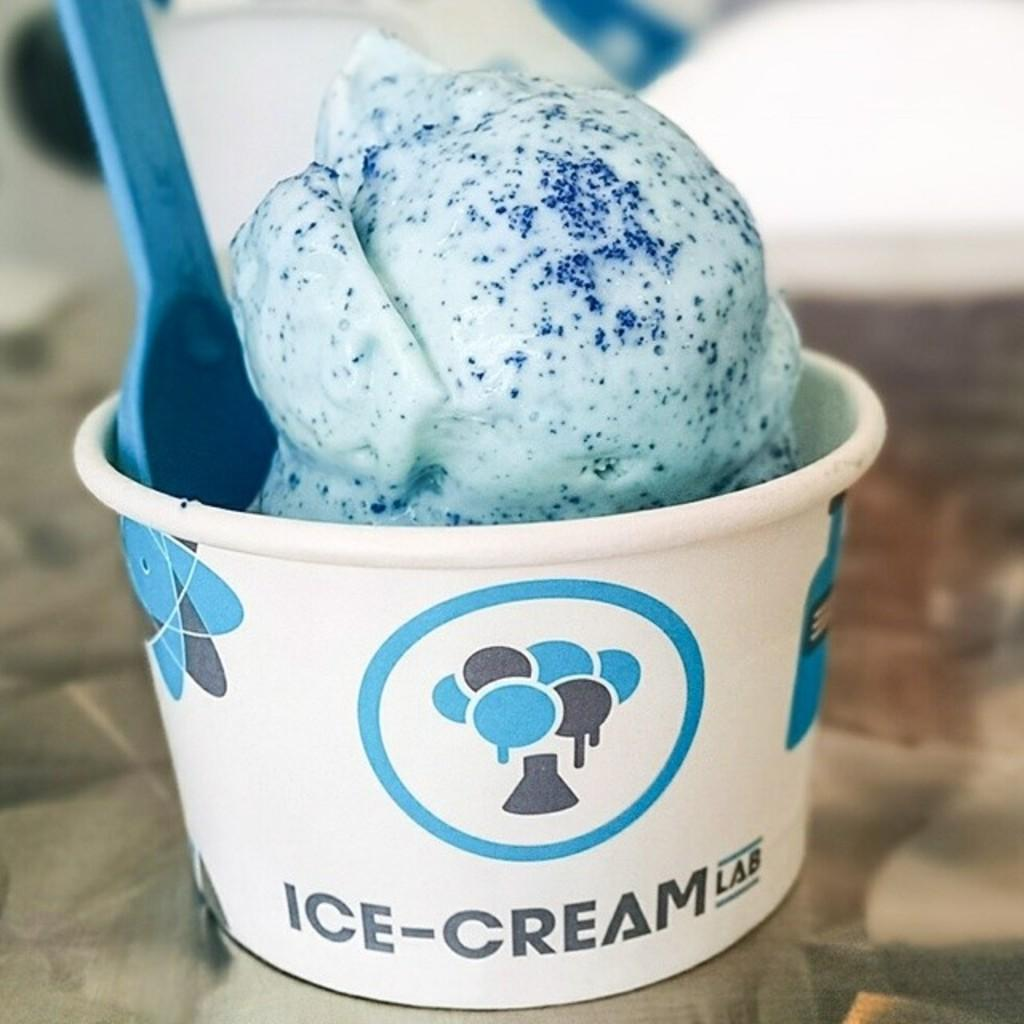What is on the table in the image? There is an ice cream on the table in the image. What else can be seen on the table besides the ice cream? There is a cup in the image. What is inside the cup? The cup contains a cream ball. What is used to eat the cream ball? There is a spoon in the cup. What is written on the cup? The cup has "ice-cream lab" written on it. Is the ice cream in jail in the image? No, there is no jail or any indication of confinement in the image. What activity is the ice cream participating in? The ice cream is not participating in any activity, as it is an inanimate object. 